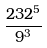Convert formula to latex. <formula><loc_0><loc_0><loc_500><loc_500>\frac { 2 3 2 ^ { 5 } } { 9 ^ { 3 } }</formula> 